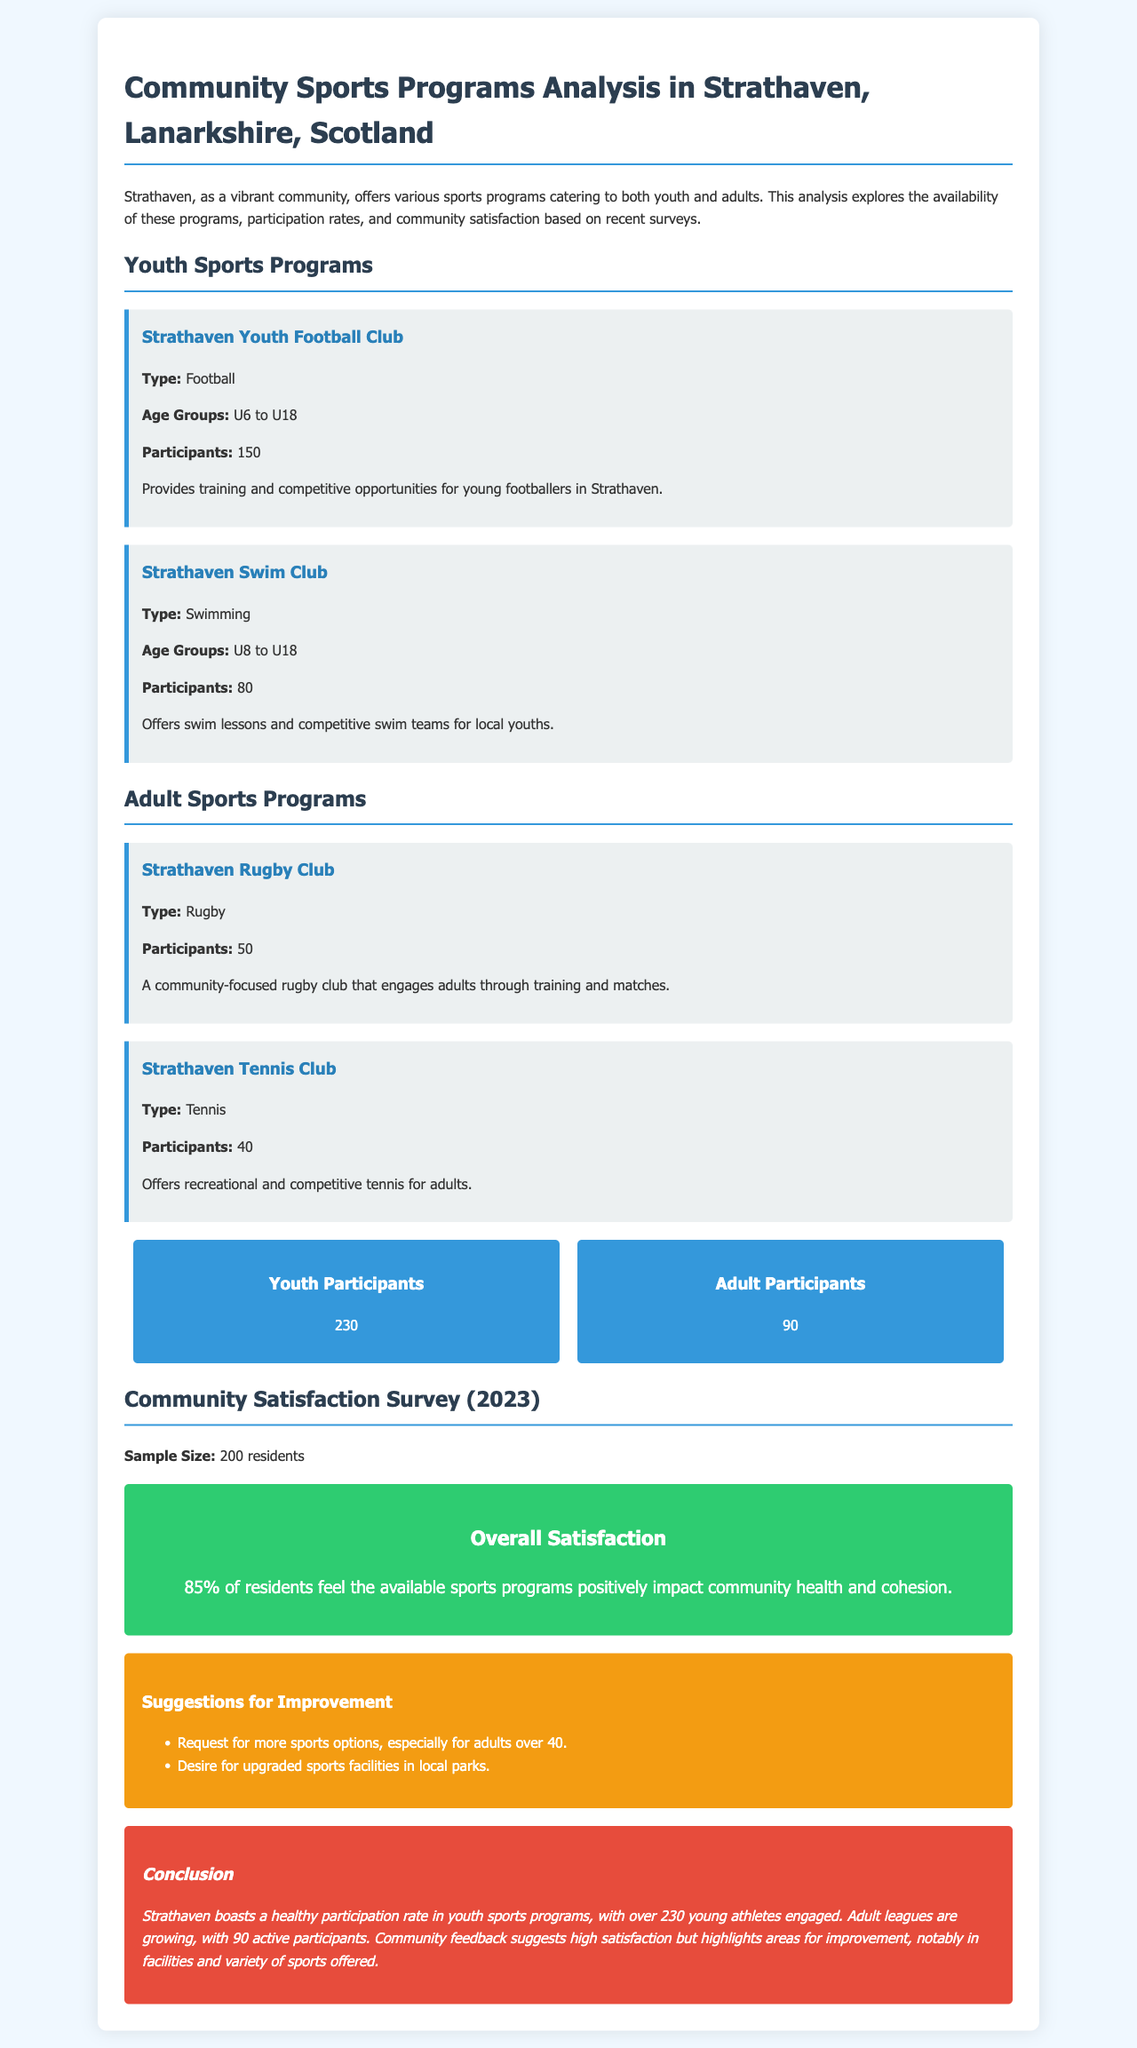What is the total number of youth participants? The total number of youth participants is mentioned in the document as 230.
Answer: 230 How many adult participants are involved in sports programs? The document states that there are 90 adult participants in sports programs.
Answer: 90 What type of sport does the Strathaven Youth Football Club offer? The document specifies that the Strathaven Youth Football Club offers football as its sport.
Answer: Football What age group does the Strathaven Swim Club cater to? The document indicates that the Strathaven Swim Club caters to age groups from U8 to U18.
Answer: U8 to U18 What percentage of residents feel positively about the sports programs? According to the document, 85% of residents feel that the sports programs positively impact community health and cohesion.
Answer: 85% Which adult sports program has the most participants? The document mentions that the Strathaven Rugby Club has 50 participants, making it the adult program with the most participation.
Answer: Strathaven Rugby Club What suggestion did residents make for improving sports options? The document includes a suggestion for more sports options, specifically for adults over 40.
Answer: More sports options for adults over 40 What is a community suggestion regarding sports facilities? The document notes a desire for upgraded sports facilities in local parks.
Answer: Upgraded sports facilities in local parks What is the conclusion about youth sports participation? The conclusion states that Strathaven boasts a healthy participation rate in youth sports, with over 230 young athletes engaged.
Answer: Healthy participation rate in youth sports 